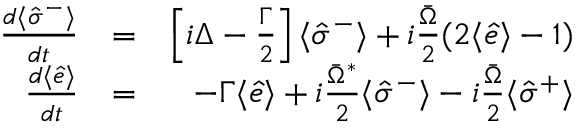<formula> <loc_0><loc_0><loc_500><loc_500>\begin{array} { r l r } { \frac { d \langle \hat { \sigma } ^ { - } \rangle } { d t } } & { = } & { \left [ i \Delta - \frac { \Gamma } { 2 } \right ] \langle \hat { \sigma } ^ { - } \rangle + i \frac { \bar { \Omega } } { 2 } ( 2 \langle \hat { e } \rangle - 1 ) } \\ { \frac { d \langle \hat { e } \rangle } { d t } } & { = } & { - \Gamma \langle \hat { e } \rangle + i \frac { \bar { \Omega } ^ { * } } { 2 } \langle \hat { \sigma } ^ { - } \rangle - i \frac { \bar { \Omega } } { 2 } \langle \hat { \sigma } ^ { + } \rangle } \end{array}</formula> 